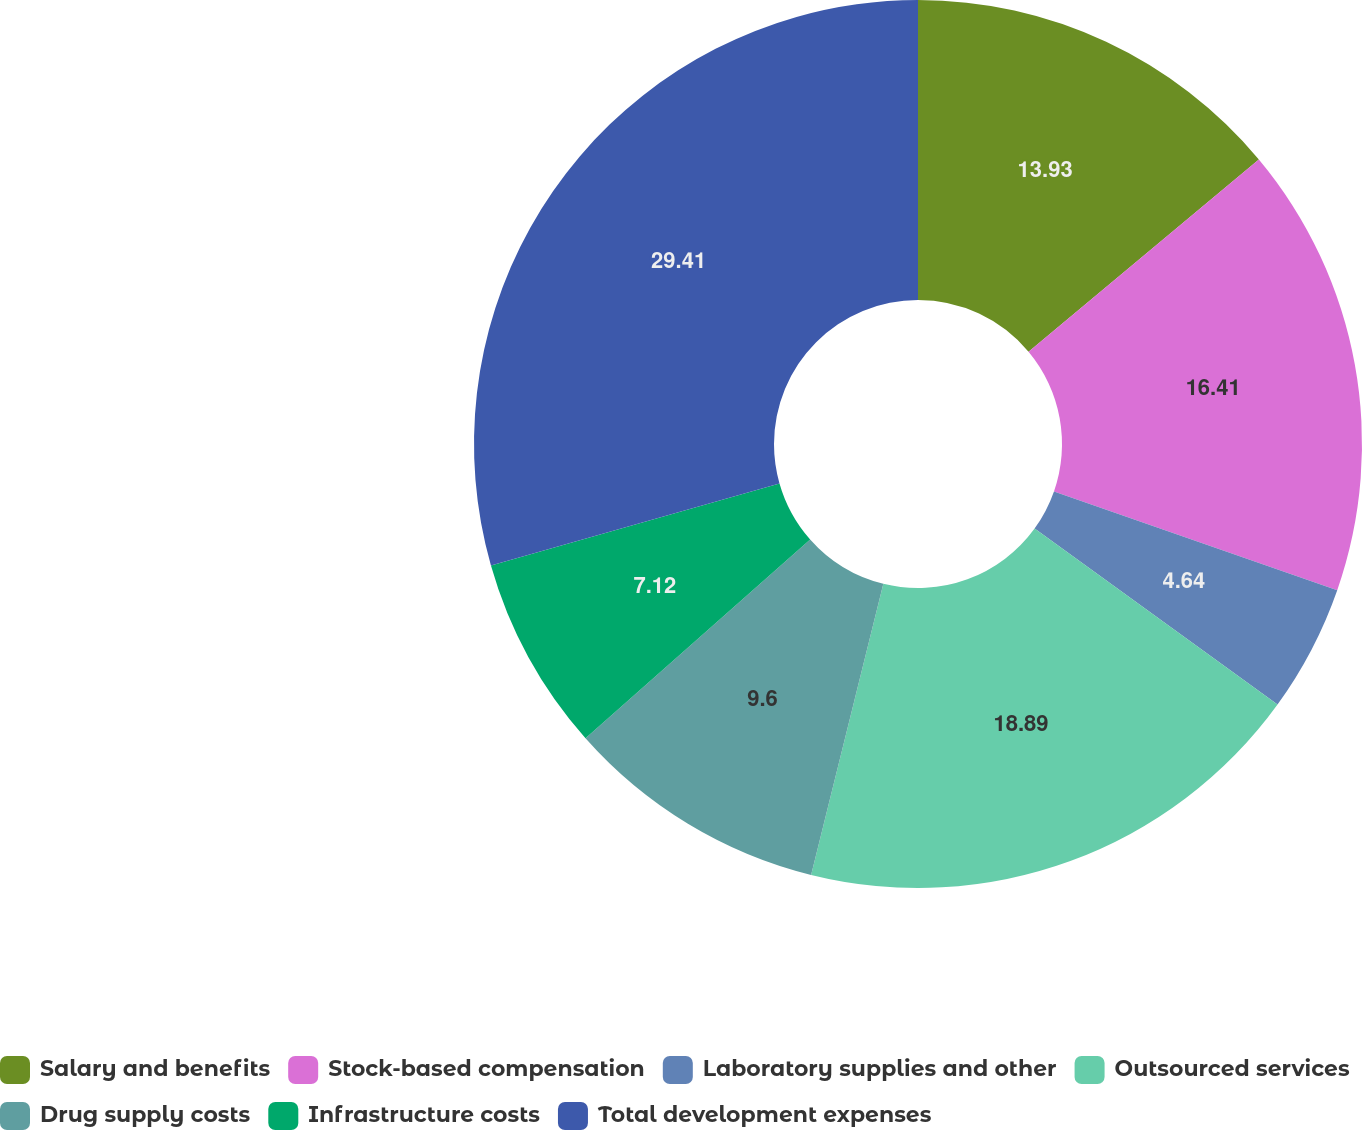Convert chart. <chart><loc_0><loc_0><loc_500><loc_500><pie_chart><fcel>Salary and benefits<fcel>Stock-based compensation<fcel>Laboratory supplies and other<fcel>Outsourced services<fcel>Drug supply costs<fcel>Infrastructure costs<fcel>Total development expenses<nl><fcel>13.93%<fcel>16.41%<fcel>4.64%<fcel>18.89%<fcel>9.6%<fcel>7.12%<fcel>29.41%<nl></chart> 